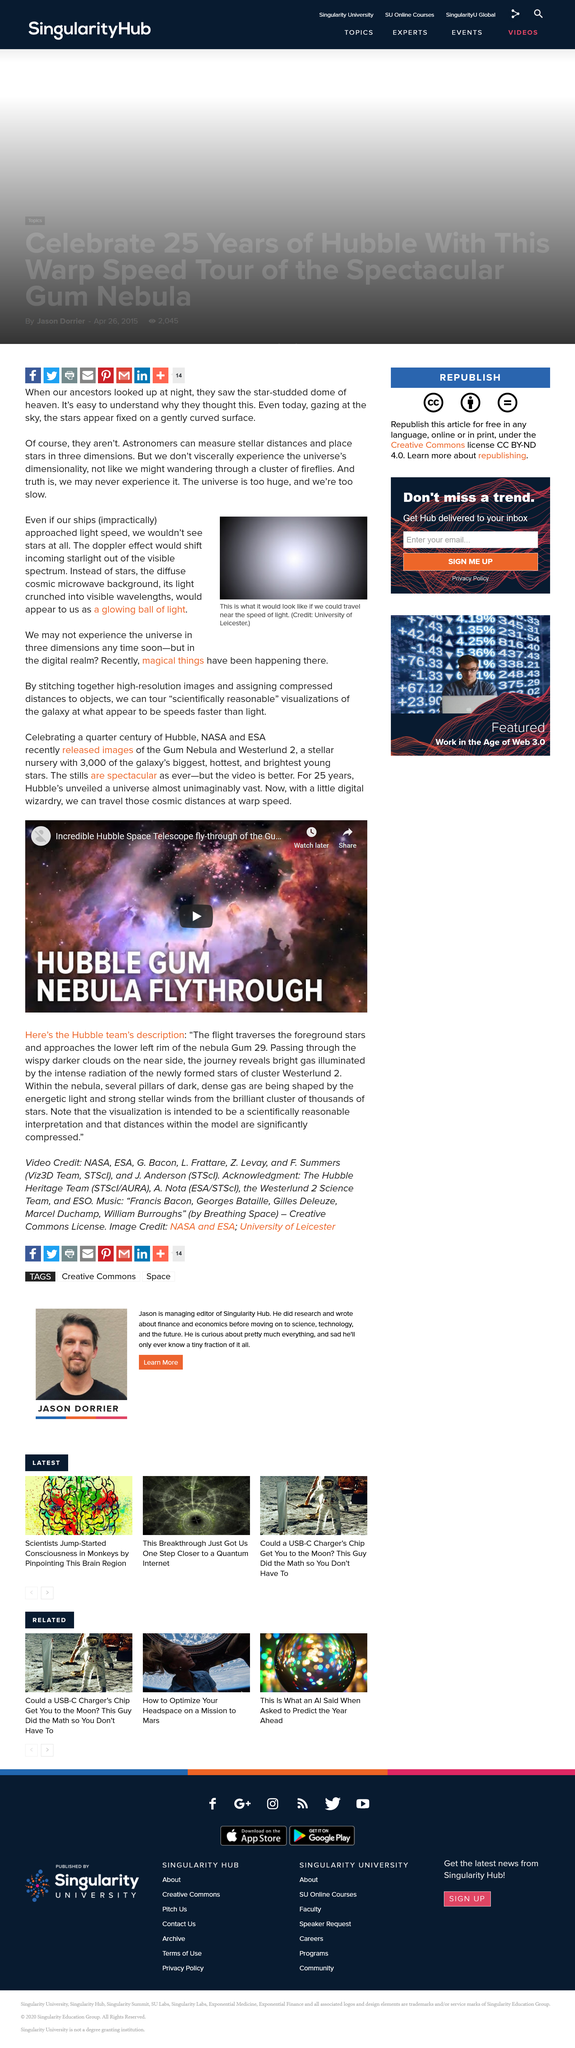Indicate a few pertinent items in this graphic. According to the article, it is impossible to see stars when approaching the speed of light, as one would not be able to see them at all. The article suggests that magical things have been happening in the digital realm. The University of Leicester is credited with creating the image. 